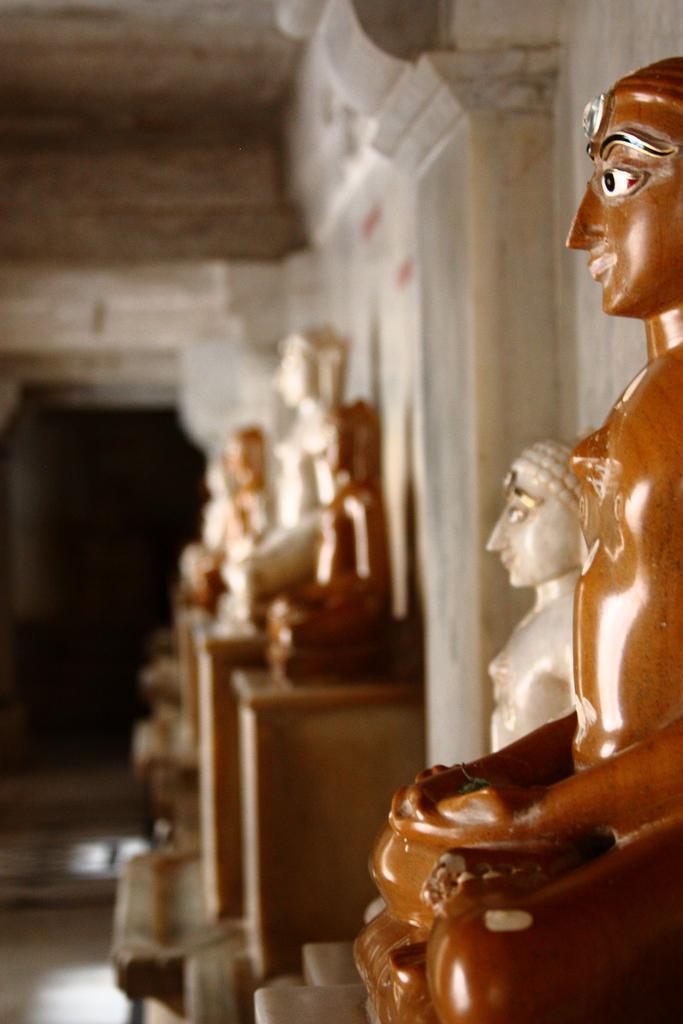Describe this image in one or two sentences. In this image we can see few sculptures. Behind the sculptures we can see a wall. At the top we can see the roof. 